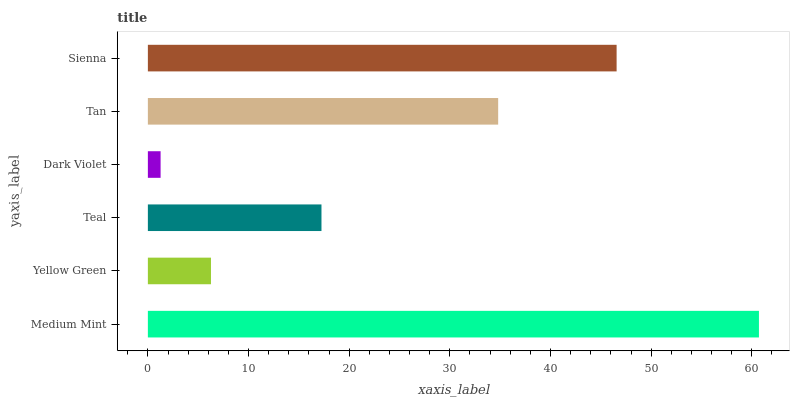Is Dark Violet the minimum?
Answer yes or no. Yes. Is Medium Mint the maximum?
Answer yes or no. Yes. Is Yellow Green the minimum?
Answer yes or no. No. Is Yellow Green the maximum?
Answer yes or no. No. Is Medium Mint greater than Yellow Green?
Answer yes or no. Yes. Is Yellow Green less than Medium Mint?
Answer yes or no. Yes. Is Yellow Green greater than Medium Mint?
Answer yes or no. No. Is Medium Mint less than Yellow Green?
Answer yes or no. No. Is Tan the high median?
Answer yes or no. Yes. Is Teal the low median?
Answer yes or no. Yes. Is Yellow Green the high median?
Answer yes or no. No. Is Tan the low median?
Answer yes or no. No. 